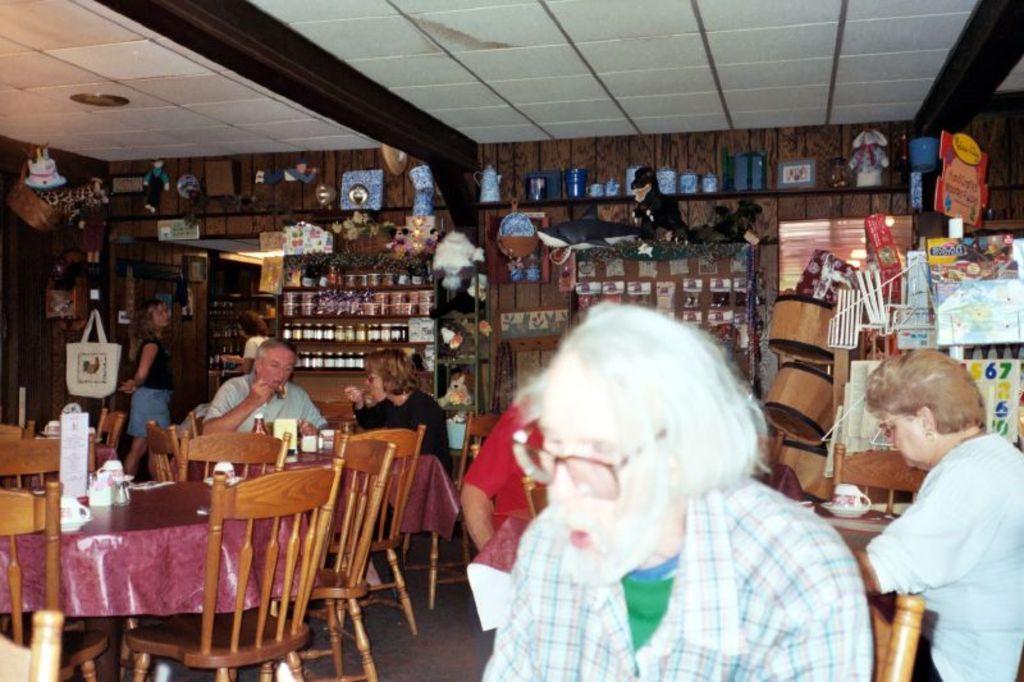Describe this image in one or two sentences. In this picture we can see some persons are sitting on the chairs. And this is the table, there is a cloth on the table. Here we can see some bottles in the rack. And there is a bag. Here we can see a woman standing on the floor. And this is the wall. 